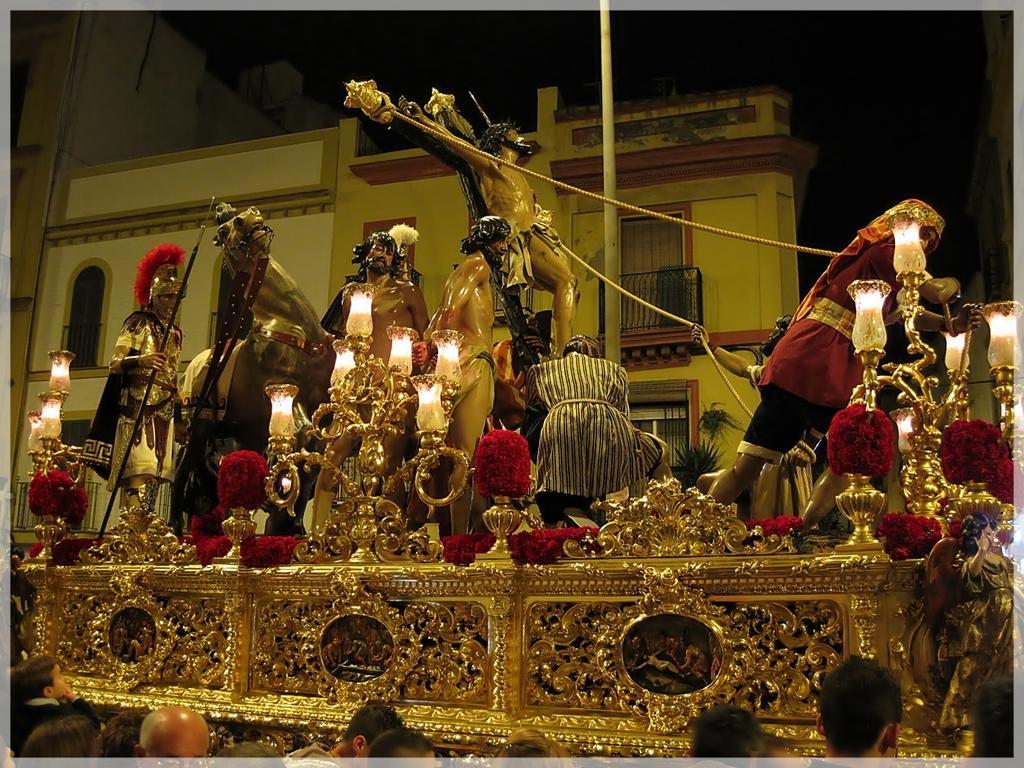Describe this image in one or two sentences. In this image we can see the group of statues. And we can see the lamps with lights. And we can see the group of people standing in front of statues. And we can see the buildings. And we can see the pole. 